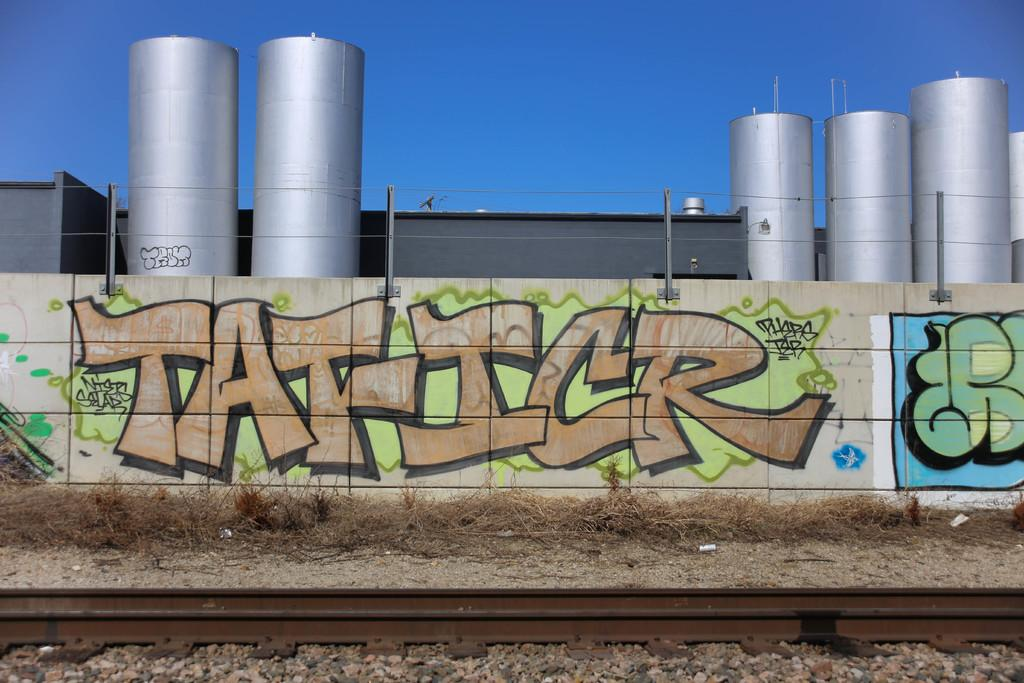<image>
Give a short and clear explanation of the subsequent image. green and yellow grafitti on a large concrete wall that says TAFICR 